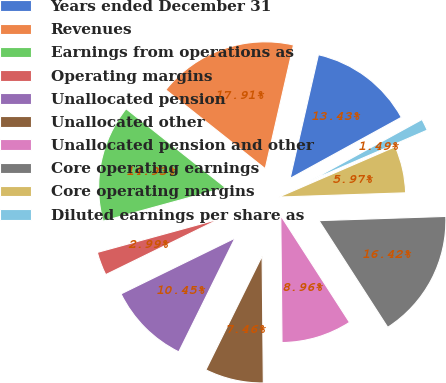Convert chart. <chart><loc_0><loc_0><loc_500><loc_500><pie_chart><fcel>Years ended December 31<fcel>Revenues<fcel>Earnings from operations as<fcel>Operating margins<fcel>Unallocated pension<fcel>Unallocated other<fcel>Unallocated pension and other<fcel>Core operating earnings<fcel>Core operating margins<fcel>Diluted earnings per share as<nl><fcel>13.43%<fcel>17.91%<fcel>14.93%<fcel>2.99%<fcel>10.45%<fcel>7.46%<fcel>8.96%<fcel>16.42%<fcel>5.97%<fcel>1.49%<nl></chart> 